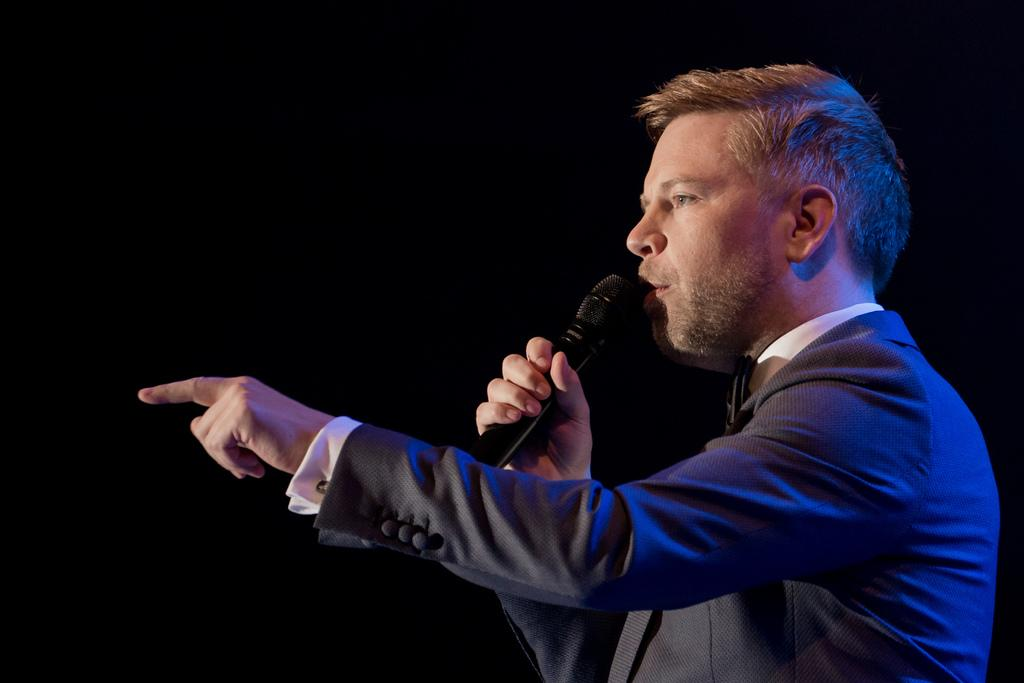Who is the main subject in the image? There is a man in the image. What is the man wearing? The man is wearing a suit. What object is the man holding in his hand? The man is holding a microphone in his hand. What is the man doing in the image? The man is talking. What type of furniture is visible in the image? There is no furniture visible in the image; it only features a man holding a microphone and talking. Can you tell me how many worms are crawling on the man's suit in the image? There are no worms present in the image; the man is wearing a suit and holding a microphone while talking. 